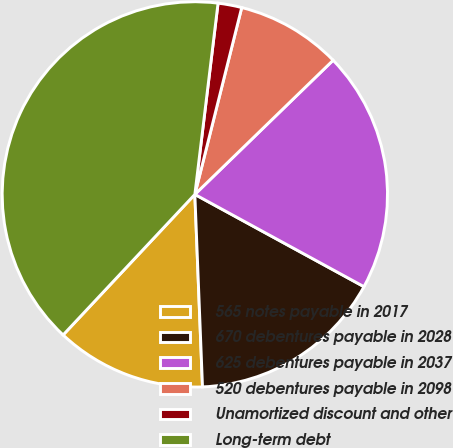Convert chart. <chart><loc_0><loc_0><loc_500><loc_500><pie_chart><fcel>565 notes payable in 2017<fcel>670 debentures payable in 2028<fcel>625 debentures payable in 2037<fcel>520 debentures payable in 2098<fcel>Unamortized discount and other<fcel>Long-term debt<nl><fcel>12.62%<fcel>16.42%<fcel>20.21%<fcel>8.83%<fcel>1.99%<fcel>39.94%<nl></chart> 